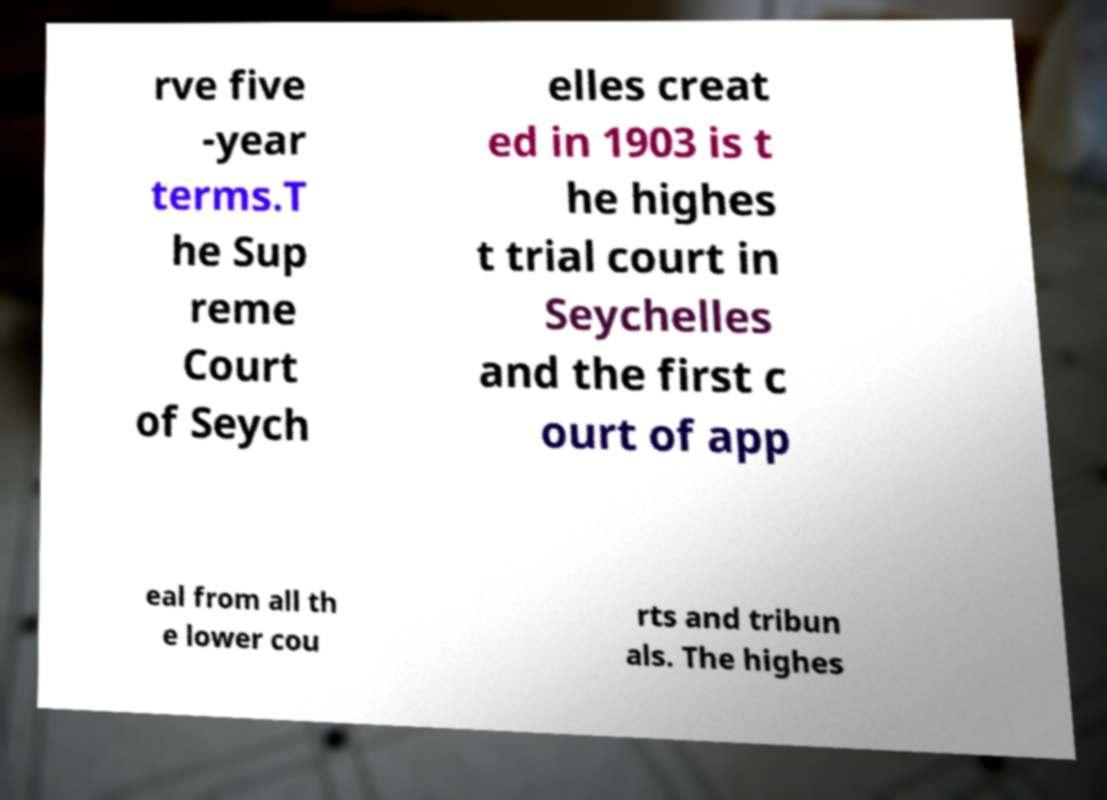Please read and relay the text visible in this image. What does it say? rve five -year terms.T he Sup reme Court of Seych elles creat ed in 1903 is t he highes t trial court in Seychelles and the first c ourt of app eal from all th e lower cou rts and tribun als. The highes 